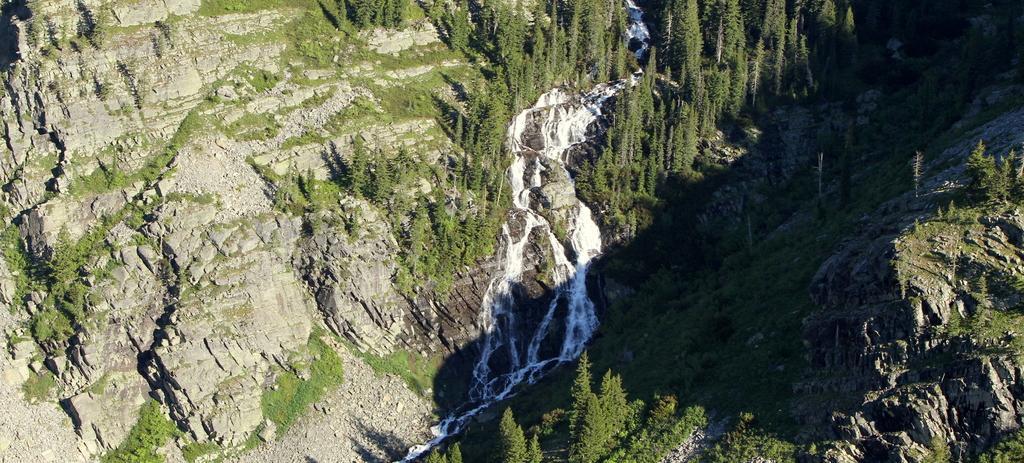Could you give a brief overview of what you see in this image? In the foreground of this image, there is a river flowing down to which trees and mountains are placed on either side of the river. 